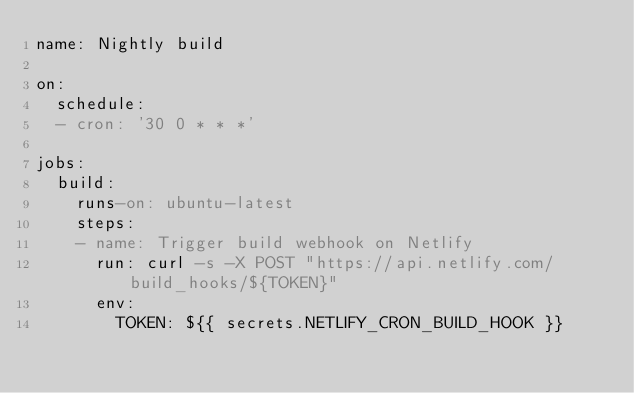<code> <loc_0><loc_0><loc_500><loc_500><_YAML_>name: Nightly build

on:
  schedule:
  - cron: '30 0 * * *'

jobs:
  build:
    runs-on: ubuntu-latest
    steps:
    - name: Trigger build webhook on Netlify
      run: curl -s -X POST "https://api.netlify.com/build_hooks/${TOKEN}"
      env:
        TOKEN: ${{ secrets.NETLIFY_CRON_BUILD_HOOK }}
</code> 